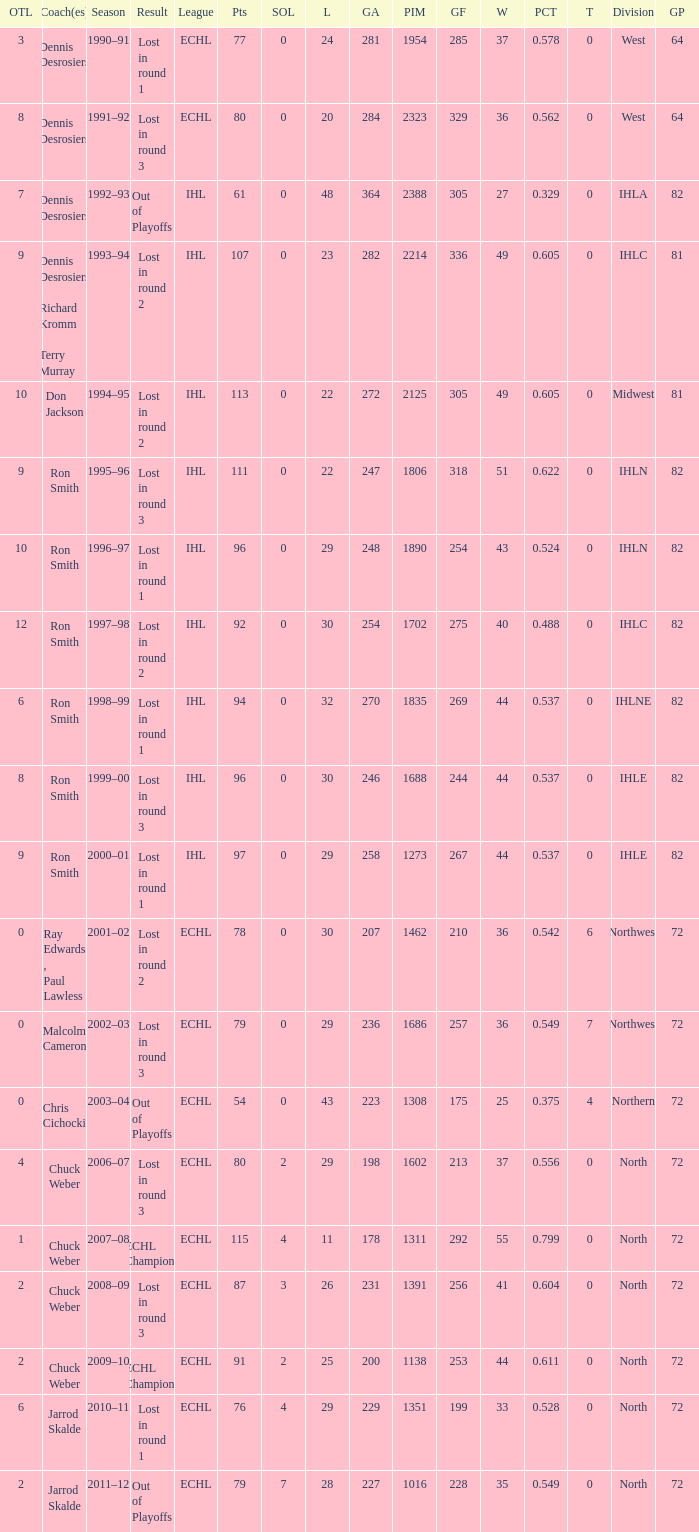How many season did the team lost in round 1 with a GP of 64? 1.0. 